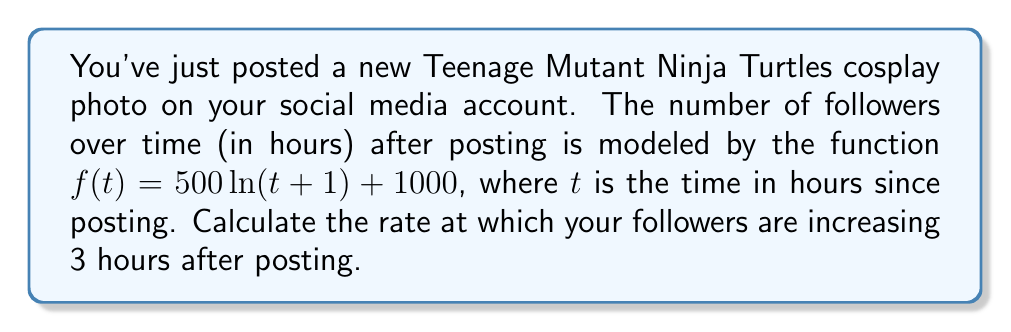Provide a solution to this math problem. To find the rate at which followers are increasing at a specific time, we need to calculate the derivative of the given function and evaluate it at the given time.

1. Given function: $f(t) = 500\ln(t+1) + 1000$

2. Calculate the derivative $f'(t)$ using the chain rule:
   $$f'(t) = 500 \cdot \frac{d}{dt}[\ln(t+1)] = 500 \cdot \frac{1}{t+1}$$

3. Evaluate $f'(t)$ at $t = 3$ hours:
   $$f'(3) = 500 \cdot \frac{1}{3+1} = 500 \cdot \frac{1}{4} = 125$$

The rate of change at 3 hours after posting is 125 followers per hour.
Answer: 125 followers/hour 